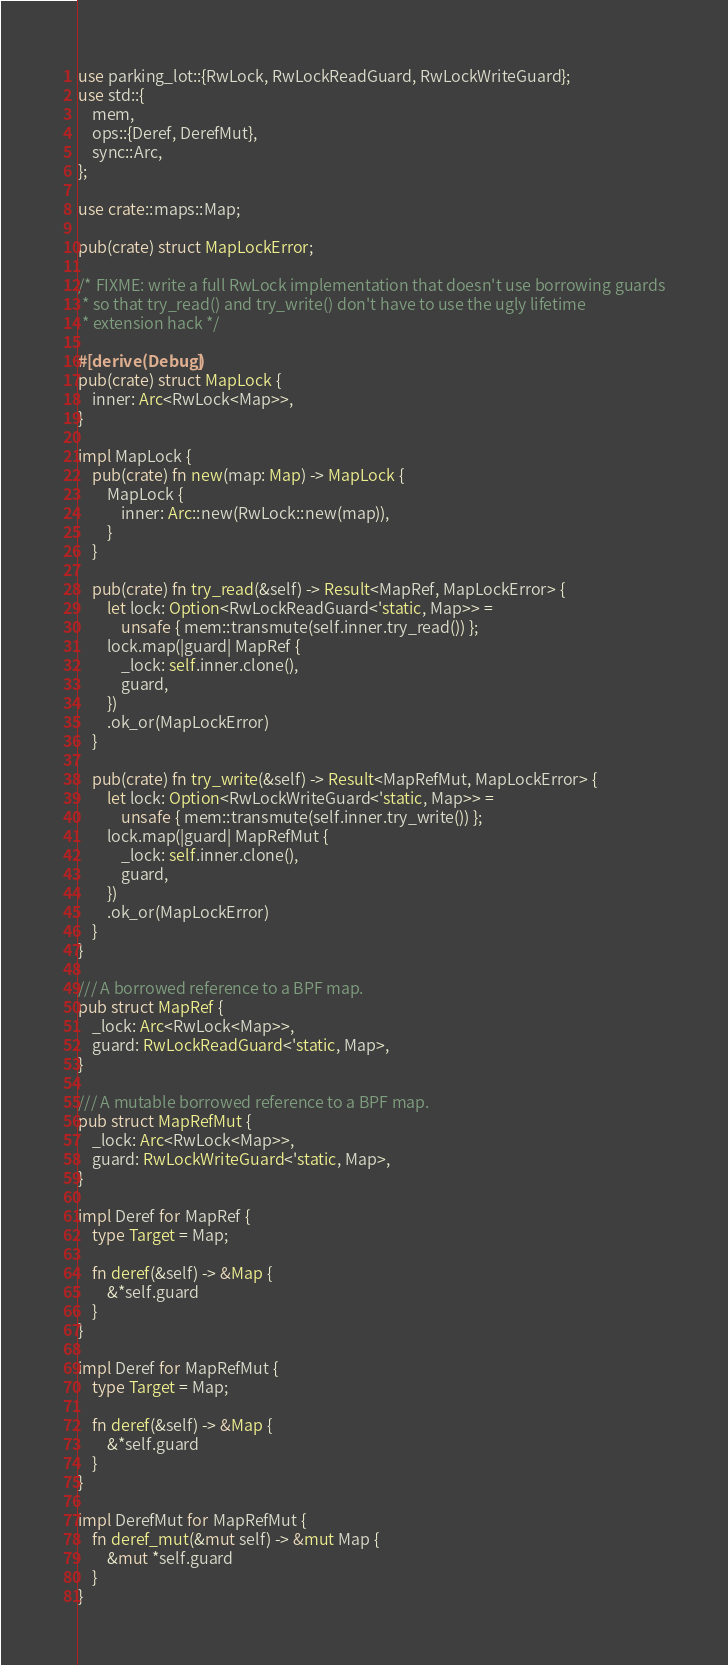<code> <loc_0><loc_0><loc_500><loc_500><_Rust_>use parking_lot::{RwLock, RwLockReadGuard, RwLockWriteGuard};
use std::{
    mem,
    ops::{Deref, DerefMut},
    sync::Arc,
};

use crate::maps::Map;

pub(crate) struct MapLockError;

/* FIXME: write a full RwLock implementation that doesn't use borrowing guards
 * so that try_read() and try_write() don't have to use the ugly lifetime
 * extension hack */

#[derive(Debug)]
pub(crate) struct MapLock {
    inner: Arc<RwLock<Map>>,
}

impl MapLock {
    pub(crate) fn new(map: Map) -> MapLock {
        MapLock {
            inner: Arc::new(RwLock::new(map)),
        }
    }

    pub(crate) fn try_read(&self) -> Result<MapRef, MapLockError> {
        let lock: Option<RwLockReadGuard<'static, Map>> =
            unsafe { mem::transmute(self.inner.try_read()) };
        lock.map(|guard| MapRef {
            _lock: self.inner.clone(),
            guard,
        })
        .ok_or(MapLockError)
    }

    pub(crate) fn try_write(&self) -> Result<MapRefMut, MapLockError> {
        let lock: Option<RwLockWriteGuard<'static, Map>> =
            unsafe { mem::transmute(self.inner.try_write()) };
        lock.map(|guard| MapRefMut {
            _lock: self.inner.clone(),
            guard,
        })
        .ok_or(MapLockError)
    }
}

/// A borrowed reference to a BPF map.
pub struct MapRef {
    _lock: Arc<RwLock<Map>>,
    guard: RwLockReadGuard<'static, Map>,
}

/// A mutable borrowed reference to a BPF map.
pub struct MapRefMut {
    _lock: Arc<RwLock<Map>>,
    guard: RwLockWriteGuard<'static, Map>,
}

impl Deref for MapRef {
    type Target = Map;

    fn deref(&self) -> &Map {
        &*self.guard
    }
}

impl Deref for MapRefMut {
    type Target = Map;

    fn deref(&self) -> &Map {
        &*self.guard
    }
}

impl DerefMut for MapRefMut {
    fn deref_mut(&mut self) -> &mut Map {
        &mut *self.guard
    }
}
</code> 